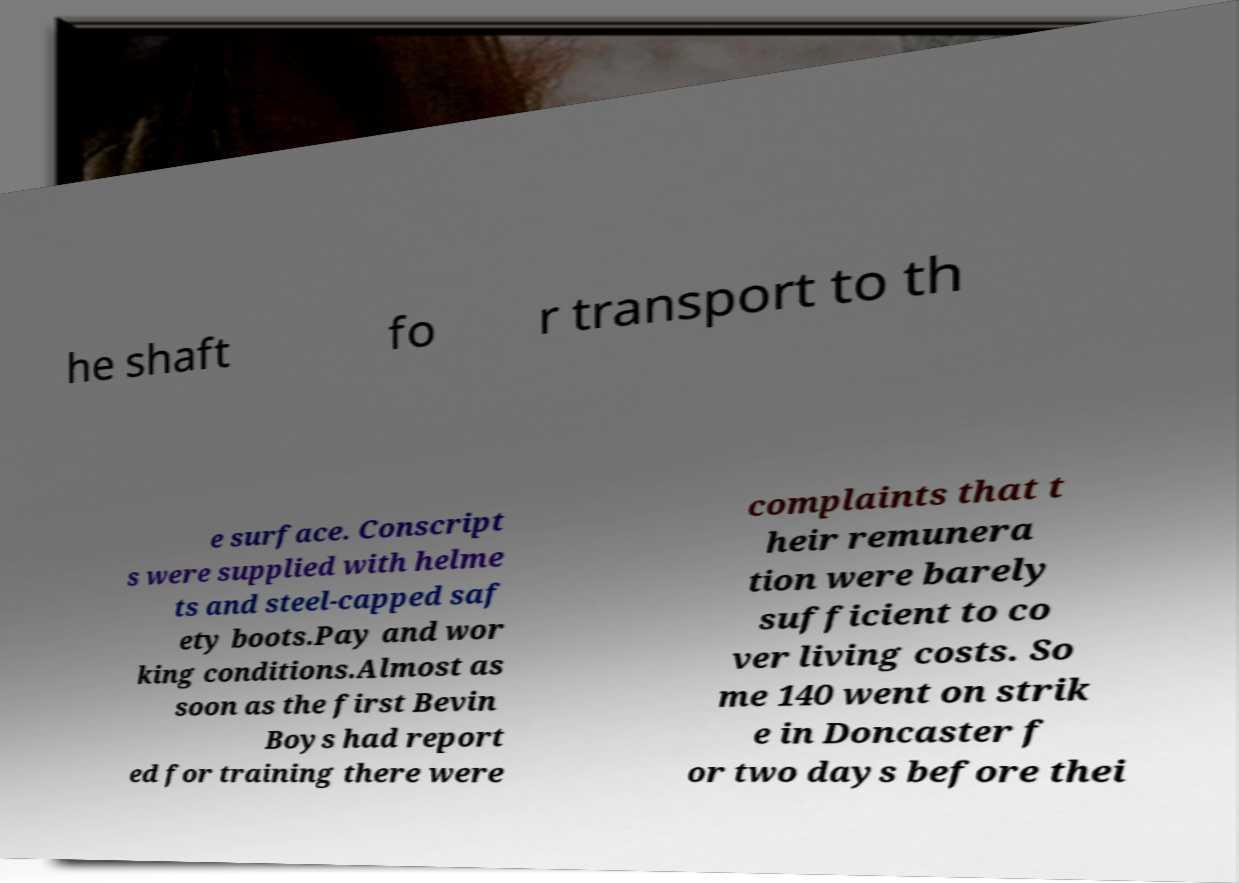For documentation purposes, I need the text within this image transcribed. Could you provide that? he shaft fo r transport to th e surface. Conscript s were supplied with helme ts and steel-capped saf ety boots.Pay and wor king conditions.Almost as soon as the first Bevin Boys had report ed for training there were complaints that t heir remunera tion were barely sufficient to co ver living costs. So me 140 went on strik e in Doncaster f or two days before thei 